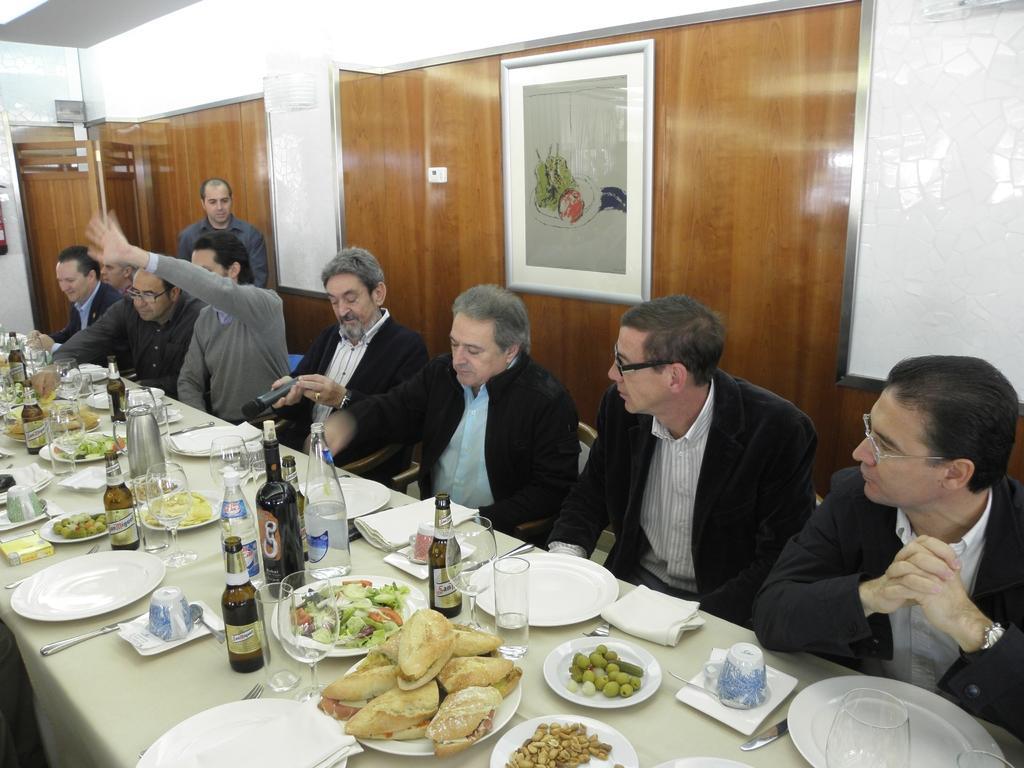Can you describe this image briefly? In this image there are group of persons sitting in chair and in table there is food , plate , tissue , glass bottle , knife and the back ground there is a frame , door. 